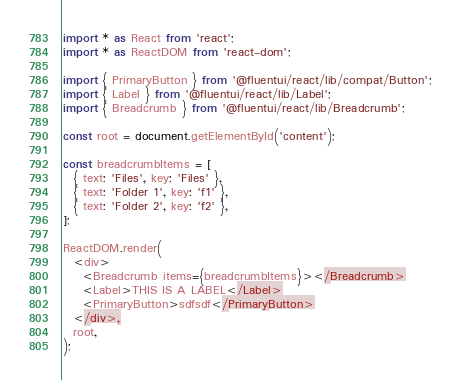Convert code to text. <code><loc_0><loc_0><loc_500><loc_500><_TypeScript_>import * as React from 'react';
import * as ReactDOM from 'react-dom';

import { PrimaryButton } from '@fluentui/react/lib/compat/Button';
import { Label } from '@fluentui/react/lib/Label';
import { Breadcrumb } from '@fluentui/react/lib/Breadcrumb';

const root = document.getElementById('content');

const breadcrumbItems = [
  { text: 'Files', key: 'Files' },
  { text: 'Folder 1', key: 'f1' },
  { text: 'Folder 2', key: 'f2' },
];

ReactDOM.render(
  <div>
    <Breadcrumb items={breadcrumbItems}></Breadcrumb>
    <Label>THIS IS A LABEL</Label>
    <PrimaryButton>sdfsdf</PrimaryButton>
  </div>,
  root,
);
</code> 